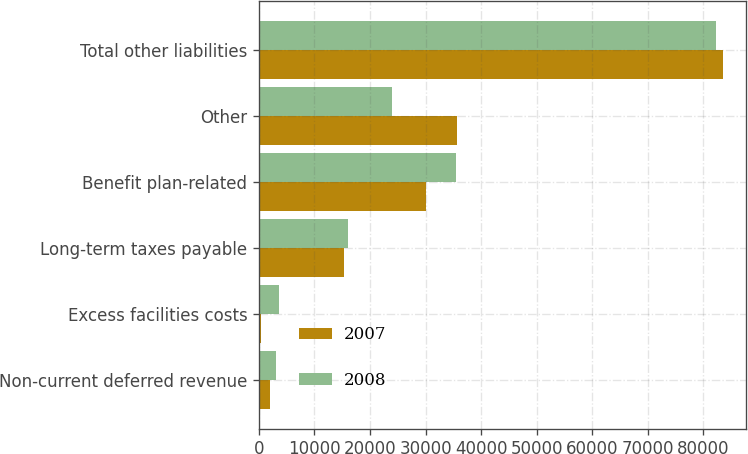<chart> <loc_0><loc_0><loc_500><loc_500><stacked_bar_chart><ecel><fcel>Non-current deferred revenue<fcel>Excess facilities costs<fcel>Long-term taxes payable<fcel>Benefit plan-related<fcel>Other<fcel>Total other liabilities<nl><fcel>2007<fcel>1913<fcel>348<fcel>15386<fcel>30098<fcel>35727<fcel>83472<nl><fcel>2008<fcel>3083<fcel>3660<fcel>16005<fcel>35545<fcel>23907<fcel>82200<nl></chart> 